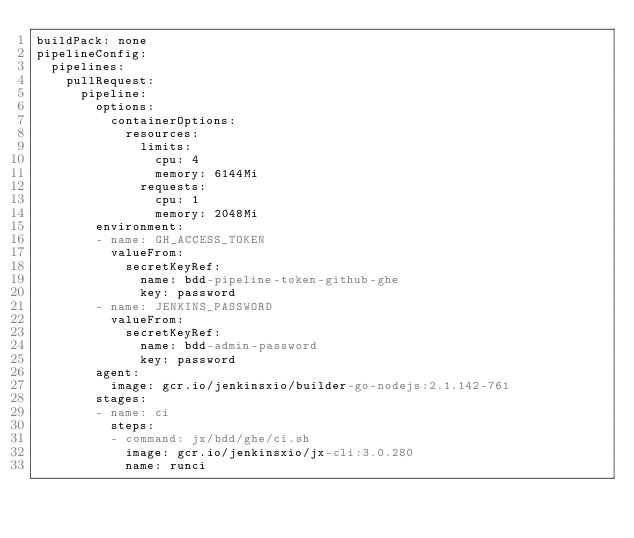Convert code to text. <code><loc_0><loc_0><loc_500><loc_500><_YAML_>buildPack: none
pipelineConfig:
  pipelines:
    pullRequest:
      pipeline:
        options:
          containerOptions:
            resources:
              limits:
                cpu: 4
                memory: 6144Mi
              requests:
                cpu: 1
                memory: 2048Mi
        environment:
        - name: GH_ACCESS_TOKEN
          valueFrom:
            secretKeyRef:
              name: bdd-pipeline-token-github-ghe
              key: password
        - name: JENKINS_PASSWORD
          valueFrom:
            secretKeyRef:
              name: bdd-admin-password
              key: password
        agent:
          image: gcr.io/jenkinsxio/builder-go-nodejs:2.1.142-761
        stages:
        - name: ci
          steps:
          - command: jx/bdd/ghe/ci.sh
            image: gcr.io/jenkinsxio/jx-cli:3.0.280
            name: runci
</code> 